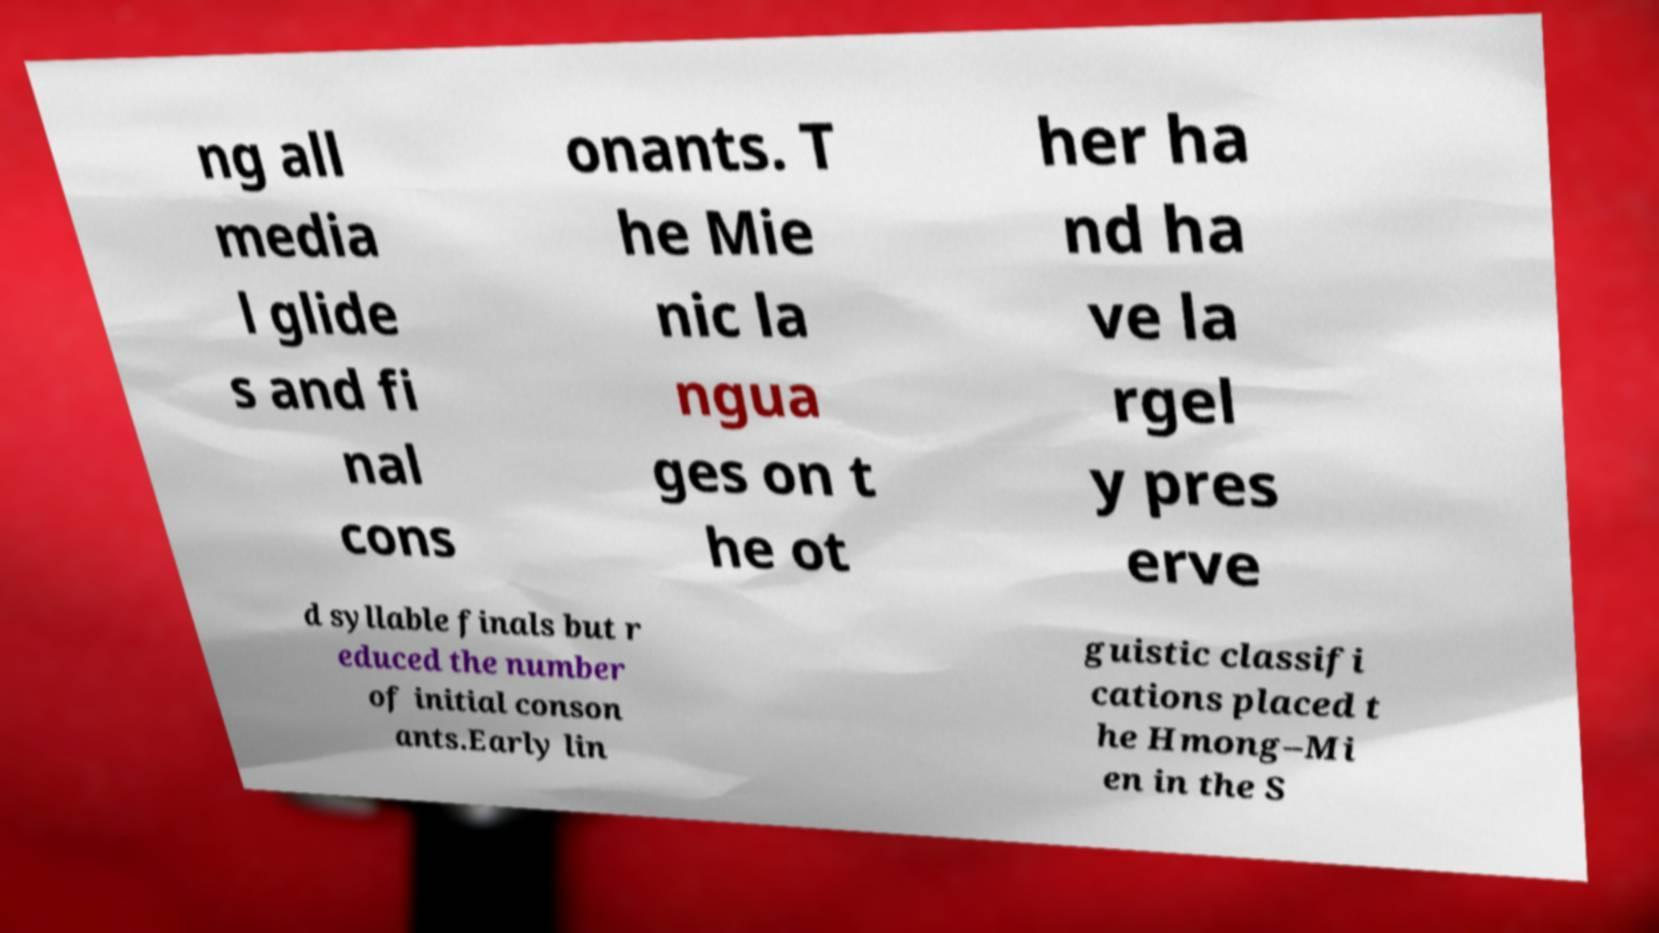There's text embedded in this image that I need extracted. Can you transcribe it verbatim? ng all media l glide s and fi nal cons onants. T he Mie nic la ngua ges on t he ot her ha nd ha ve la rgel y pres erve d syllable finals but r educed the number of initial conson ants.Early lin guistic classifi cations placed t he Hmong–Mi en in the S 